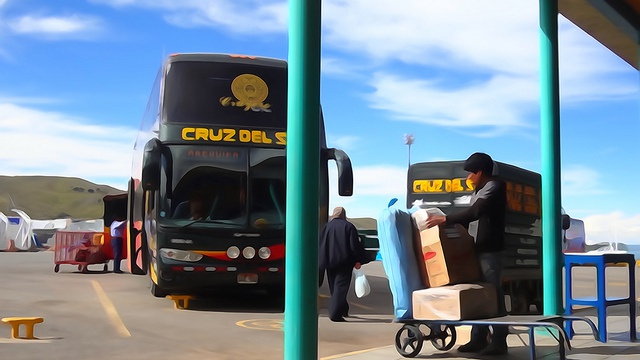Describe the objects in this image and their specific colors. I can see bus in lavender, black, gray, and maroon tones, bus in lavender, black, gray, maroon, and orange tones, truck in lavender, black, gray, maroon, and orange tones, people in lavender, black, gray, and maroon tones, and people in lavender, black, gray, and darkgray tones in this image. 